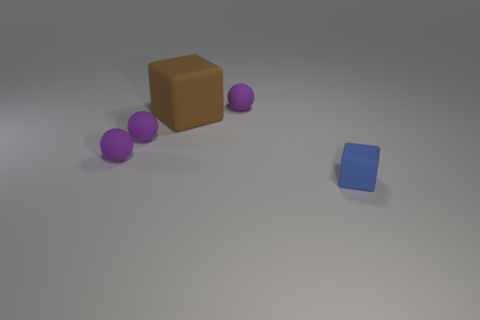Can you describe the arrangement of the objects in the image? Certainly! The image features a series of purple spheres aligned in a diagonal formation, leading towards a large brown cube. Separately, a smaller blue cube sits apart from the alignment, creating a sense of asymmetry in the composition. 